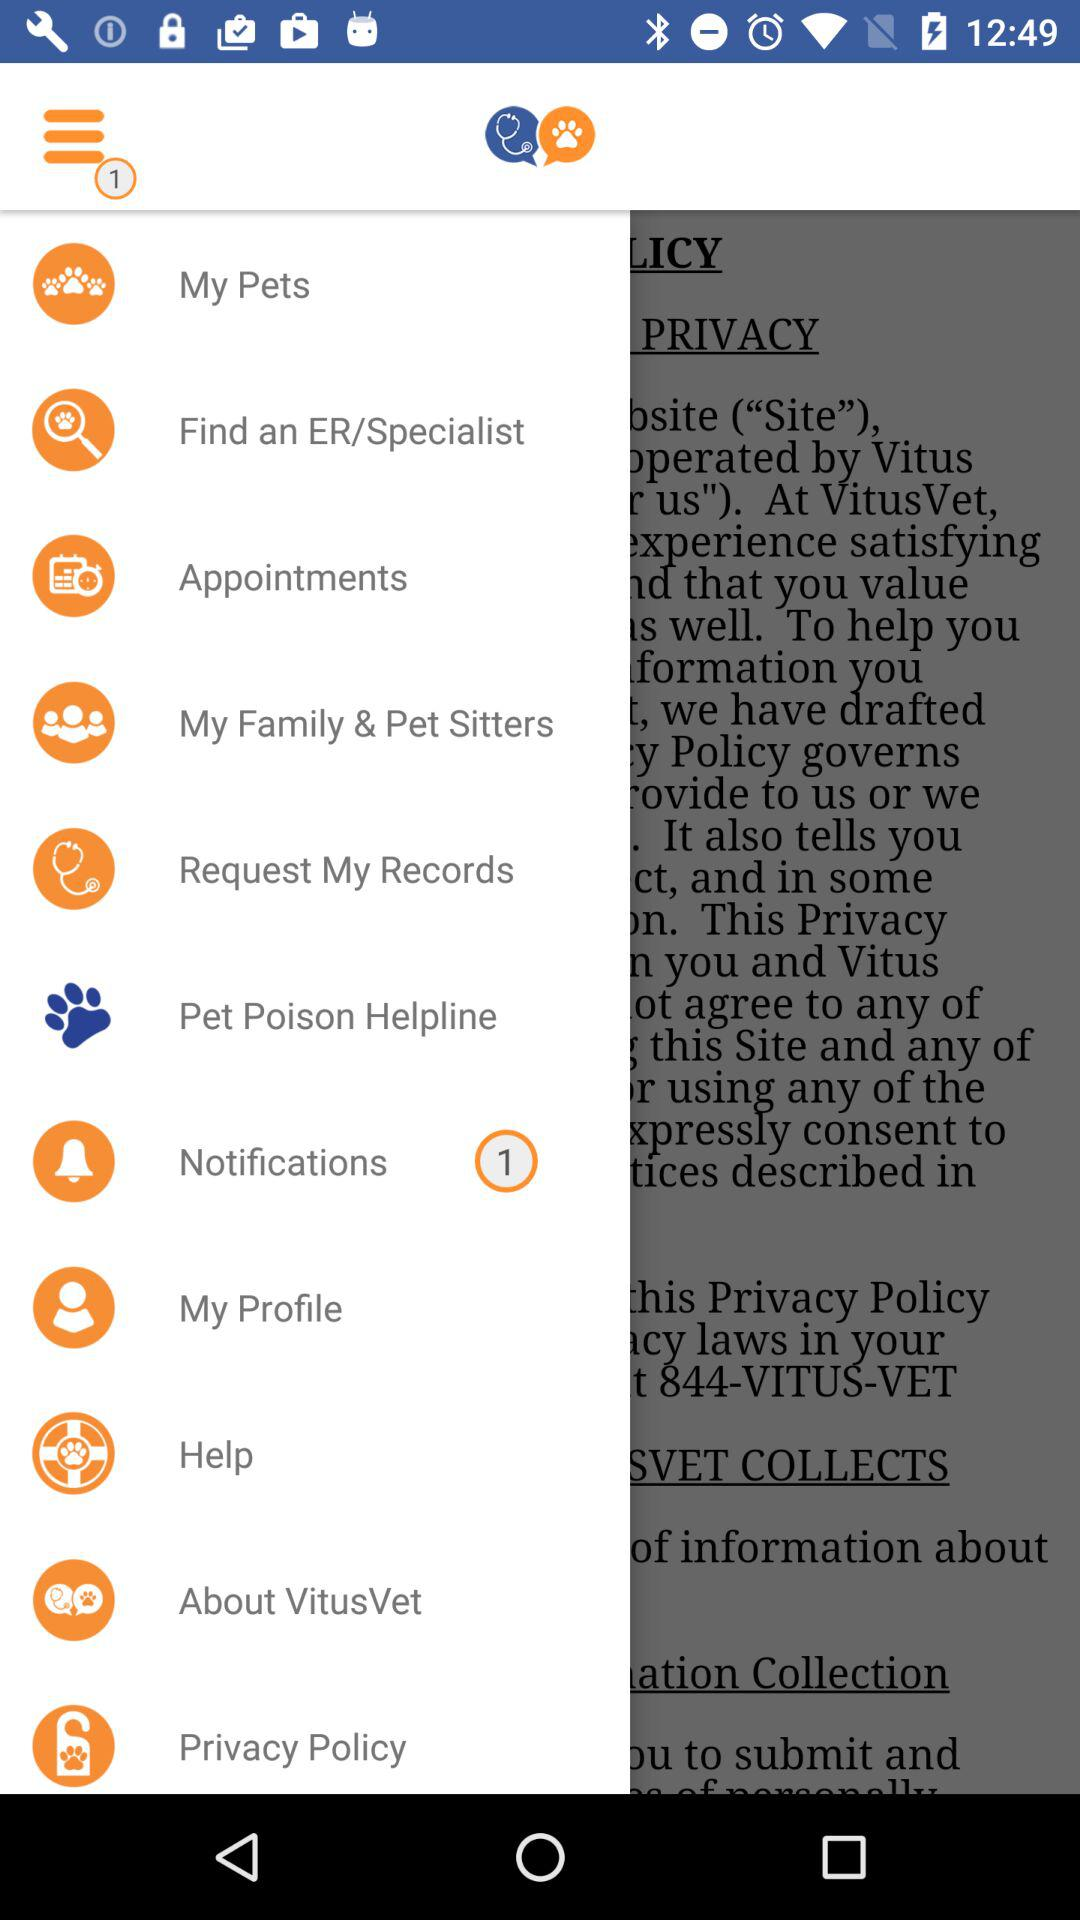Is there any notification? There is 1 notification. 